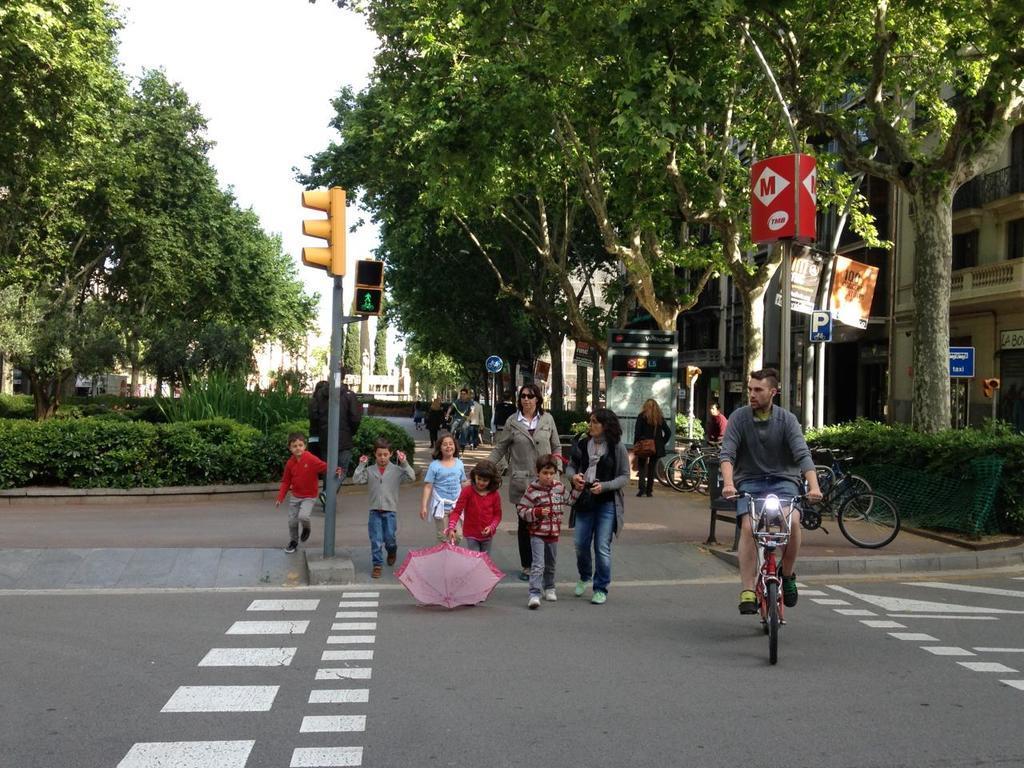Describe this image in one or two sentences. In this image, we can see some trees and plants. There are persons and kids in the middle of the image wearing clothes. There is a person wearing clothes and riding a bicycle. There are poles beside the road. There is a building on the right side of the image. There is a sky at the top of the image. 